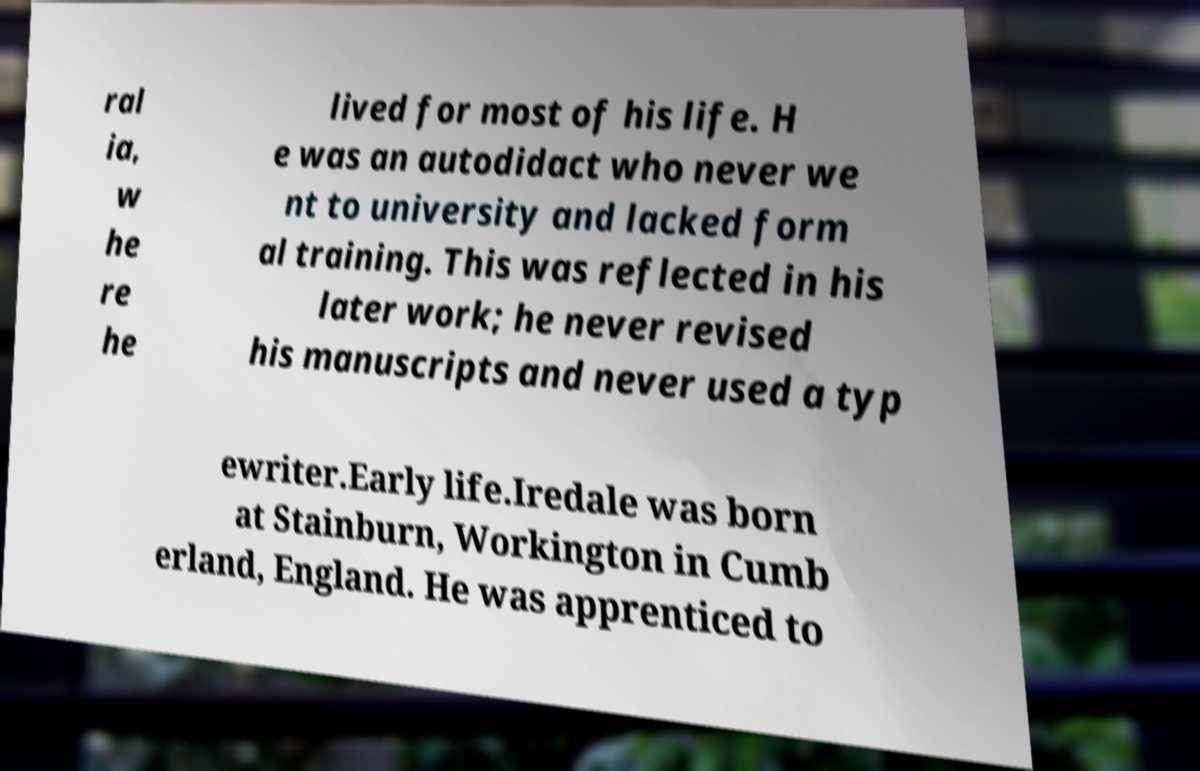Can you read and provide the text displayed in the image?This photo seems to have some interesting text. Can you extract and type it out for me? ral ia, w he re he lived for most of his life. H e was an autodidact who never we nt to university and lacked form al training. This was reflected in his later work; he never revised his manuscripts and never used a typ ewriter.Early life.Iredale was born at Stainburn, Workington in Cumb erland, England. He was apprenticed to 